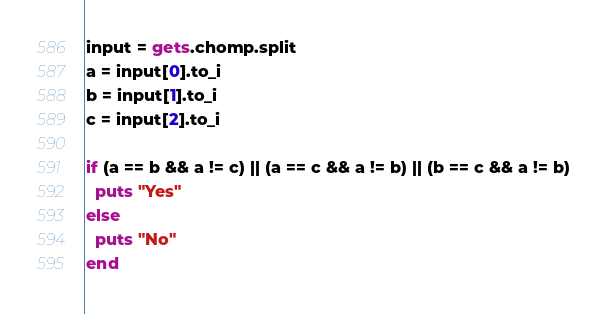<code> <loc_0><loc_0><loc_500><loc_500><_Ruby_>input = gets.chomp.split
a = input[0].to_i
b = input[1].to_i
c = input[2].to_i

if (a == b && a != c) || (a == c && a != b) || (b == c && a != b)
  puts "Yes"
else
  puts "No"
end</code> 